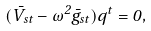Convert formula to latex. <formula><loc_0><loc_0><loc_500><loc_500>( \bar { V } _ { s t } - \omega ^ { 2 } \bar { g } _ { s t } ) q ^ { t } = 0 ,</formula> 